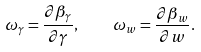<formula> <loc_0><loc_0><loc_500><loc_500>\omega _ { \gamma } = \frac { \partial \beta _ { \gamma } } { \partial { \gamma } } , \quad \omega _ { w } = \frac { \partial \beta _ { w } } { \partial { w } } .</formula> 